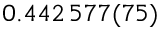Convert formula to latex. <formula><loc_0><loc_0><loc_500><loc_500>0 . 4 4 2 \, 5 7 7 ( 7 5 )</formula> 